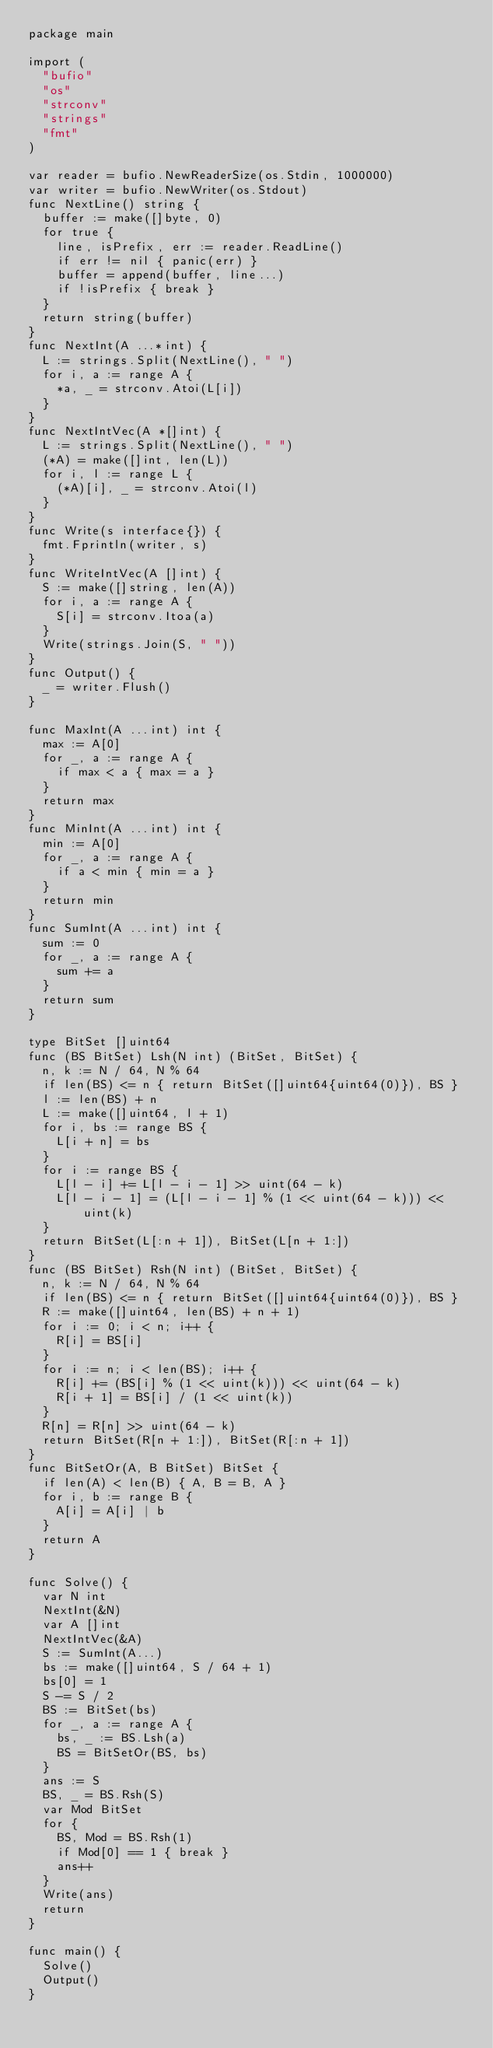Convert code to text. <code><loc_0><loc_0><loc_500><loc_500><_Go_>package main

import (
  "bufio"
  "os"
  "strconv"
  "strings"
  "fmt"
)

var reader = bufio.NewReaderSize(os.Stdin, 1000000)
var writer = bufio.NewWriter(os.Stdout)
func NextLine() string {
  buffer := make([]byte, 0)
  for true {
    line, isPrefix, err := reader.ReadLine()
    if err != nil { panic(err) }
    buffer = append(buffer, line...)
    if !isPrefix { break }
  }
  return string(buffer)
}
func NextInt(A ...*int) {
  L := strings.Split(NextLine(), " ")
  for i, a := range A {
    *a, _ = strconv.Atoi(L[i])
  }
}
func NextIntVec(A *[]int) {
  L := strings.Split(NextLine(), " ")
  (*A) = make([]int, len(L))
  for i, l := range L {
    (*A)[i], _ = strconv.Atoi(l)
  }
}
func Write(s interface{}) {
  fmt.Fprintln(writer, s)
}
func WriteIntVec(A []int) {
  S := make([]string, len(A))
  for i, a := range A {
    S[i] = strconv.Itoa(a)
  }
  Write(strings.Join(S, " "))
}
func Output() {
  _ = writer.Flush()
}

func MaxInt(A ...int) int {
  max := A[0]
  for _, a := range A {
    if max < a { max = a }
  }
  return max
}
func MinInt(A ...int) int {
  min := A[0]
  for _, a := range A {
    if a < min { min = a }
  }
  return min
}
func SumInt(A ...int) int {
  sum := 0
  for _, a := range A {
    sum += a
  }
  return sum
}

type BitSet []uint64
func (BS BitSet) Lsh(N int) (BitSet, BitSet) {
  n, k := N / 64, N % 64
  if len(BS) <= n { return BitSet([]uint64{uint64(0)}), BS }
  l := len(BS) + n
  L := make([]uint64, l + 1)
  for i, bs := range BS {
    L[i + n] = bs
  }
  for i := range BS {
    L[l - i] += L[l - i - 1] >> uint(64 - k)
    L[l - i - 1] = (L[l - i - 1] % (1 << uint(64 - k))) << uint(k)
  }
  return BitSet(L[:n + 1]), BitSet(L[n + 1:])
}
func (BS BitSet) Rsh(N int) (BitSet, BitSet) {
  n, k := N / 64, N % 64
  if len(BS) <= n { return BitSet([]uint64{uint64(0)}), BS }
  R := make([]uint64, len(BS) + n + 1)
  for i := 0; i < n; i++ {
    R[i] = BS[i]
  }
  for i := n; i < len(BS); i++ {
    R[i] += (BS[i] % (1 << uint(k))) << uint(64 - k)
    R[i + 1] = BS[i] / (1 << uint(k))
  }
  R[n] = R[n] >> uint(64 - k)
  return BitSet(R[n + 1:]), BitSet(R[:n + 1])
}
func BitSetOr(A, B BitSet) BitSet {
  if len(A) < len(B) { A, B = B, A }
  for i, b := range B {
    A[i] = A[i] | b
  }
  return A
}

func Solve() {
  var N int
  NextInt(&N)
  var A []int
  NextIntVec(&A)
  S := SumInt(A...)
  bs := make([]uint64, S / 64 + 1)
  bs[0] = 1
  S -= S / 2
  BS := BitSet(bs)
  for _, a := range A {
    bs, _ := BS.Lsh(a)
    BS = BitSetOr(BS, bs)
  }
  ans := S
  BS, _ = BS.Rsh(S)
  var Mod BitSet
  for {
    BS, Mod = BS.Rsh(1)
    if Mod[0] == 1 { break }
    ans++
  }
  Write(ans)
  return
}

func main() {
  Solve()
  Output()
}</code> 